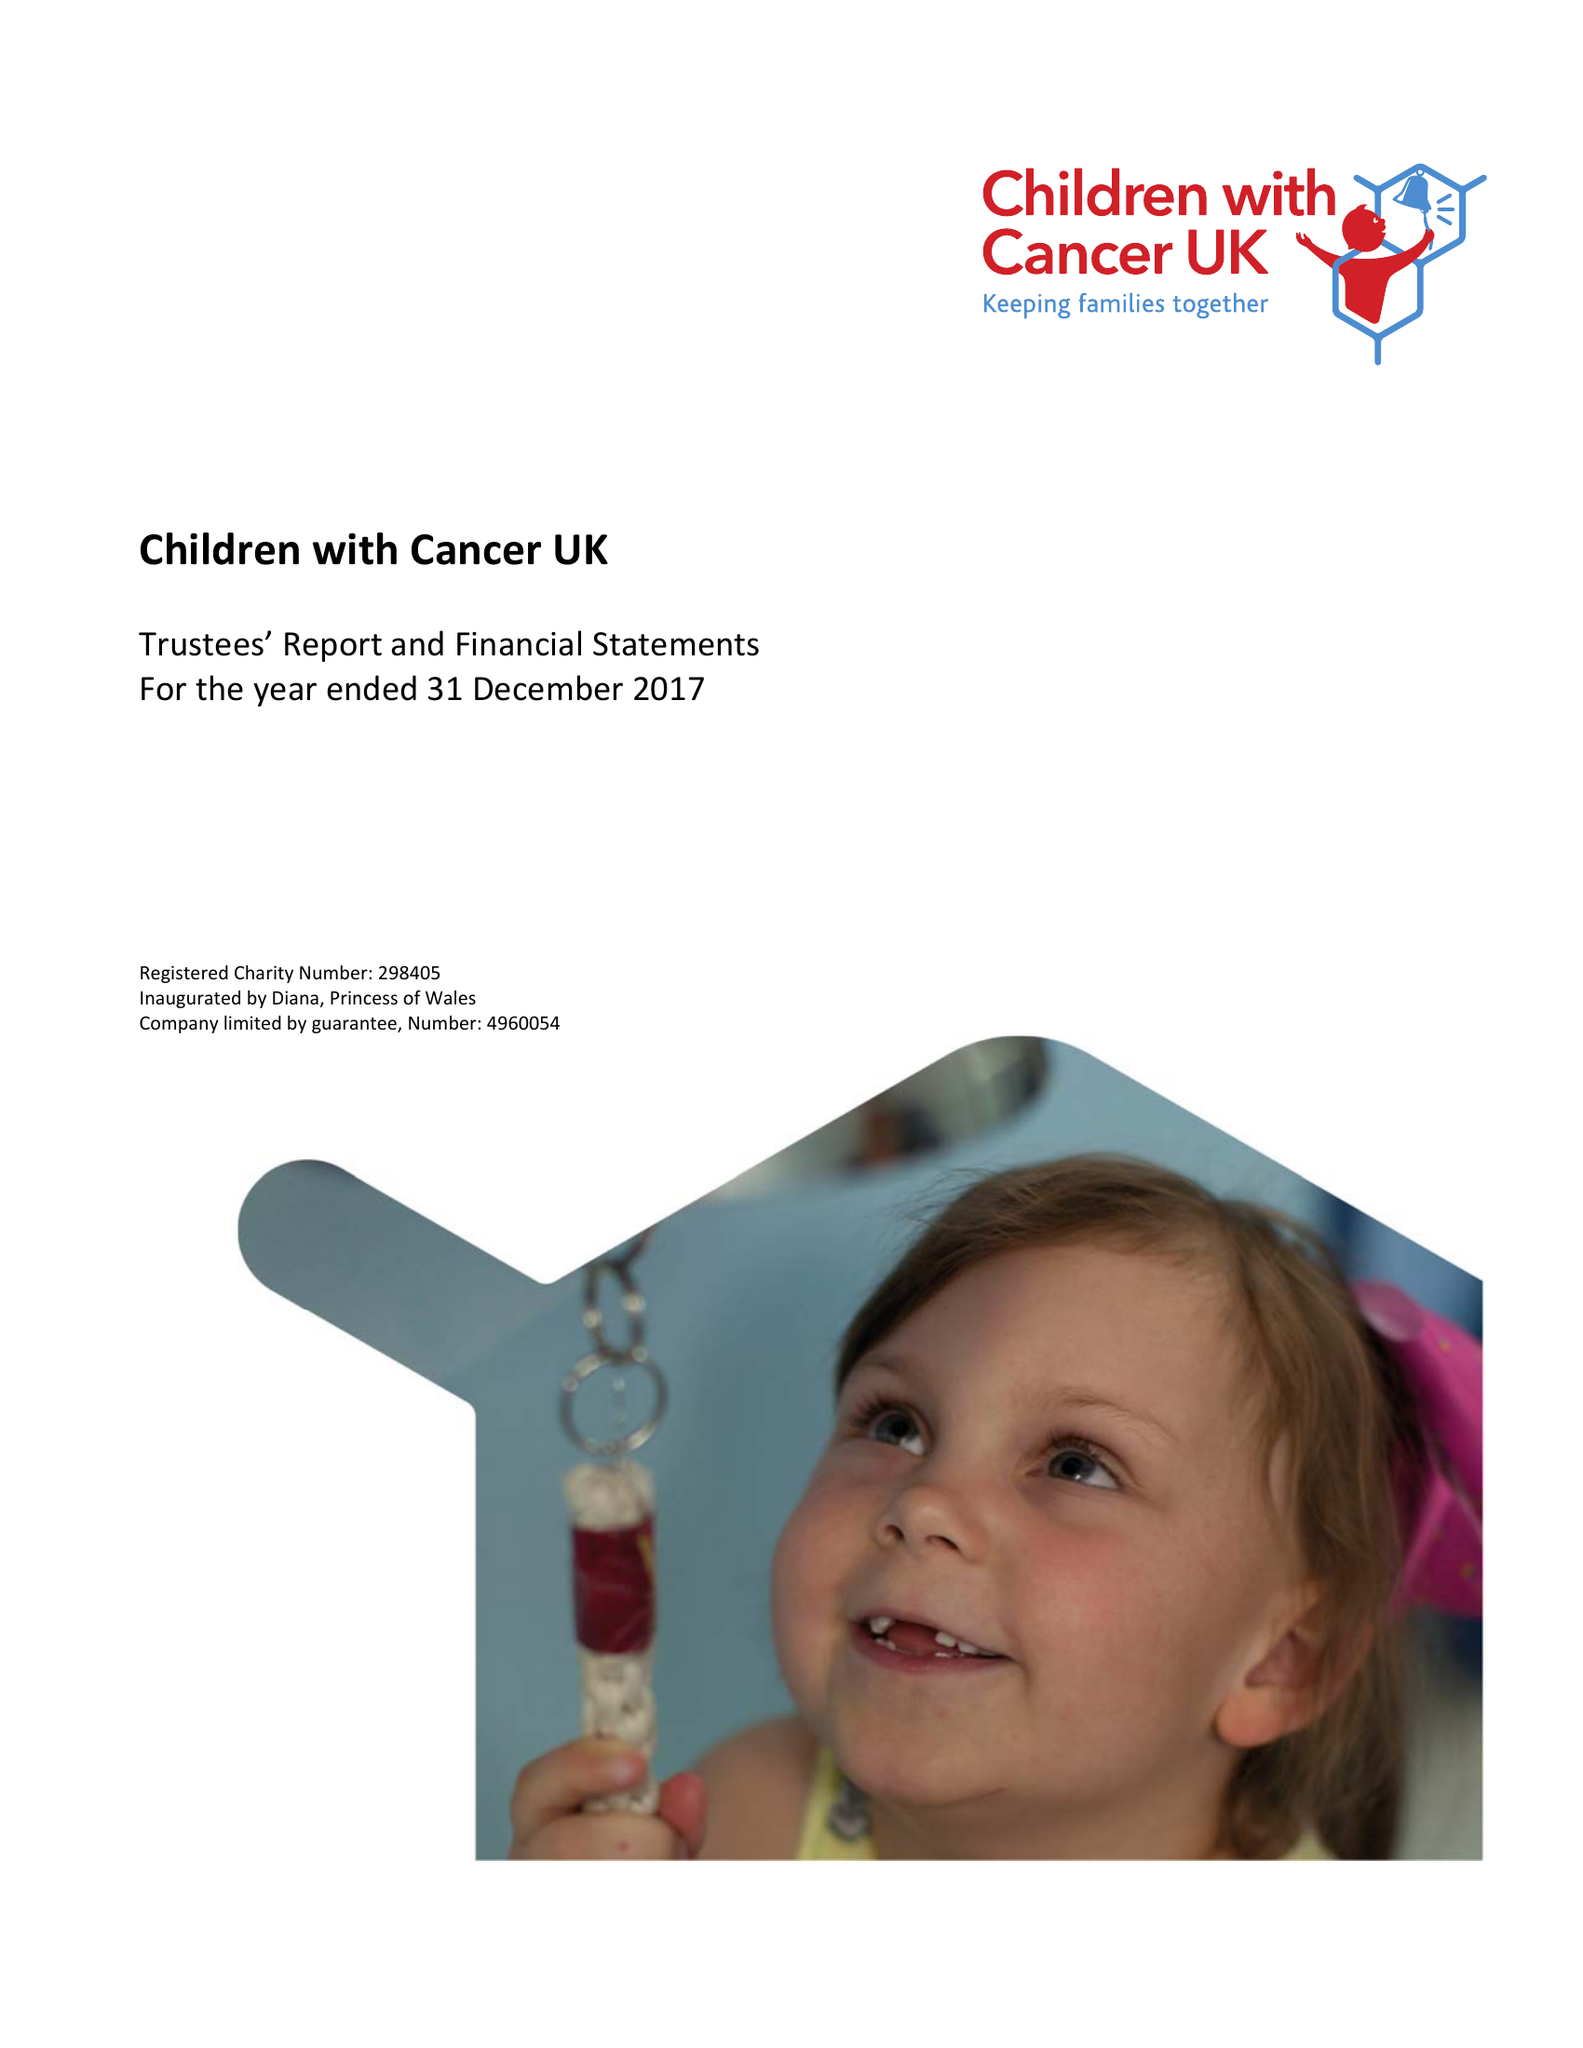What is the value for the address__post_town?
Answer the question using a single word or phrase. LONDON 